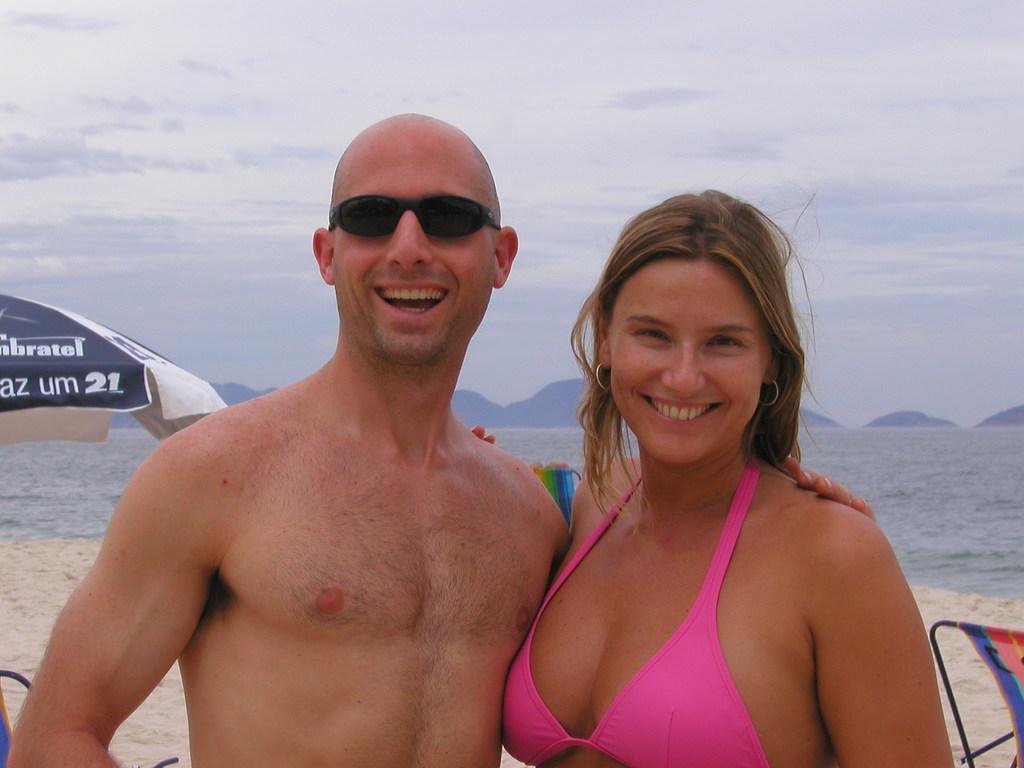Describe this image in one or two sentences. In the picture we can see a man and a woman are standing together and smiling and behind them, we can see a sand surface and a part of an umbrella and behind it, we can see water and in the background we can see a sky with clouds. 